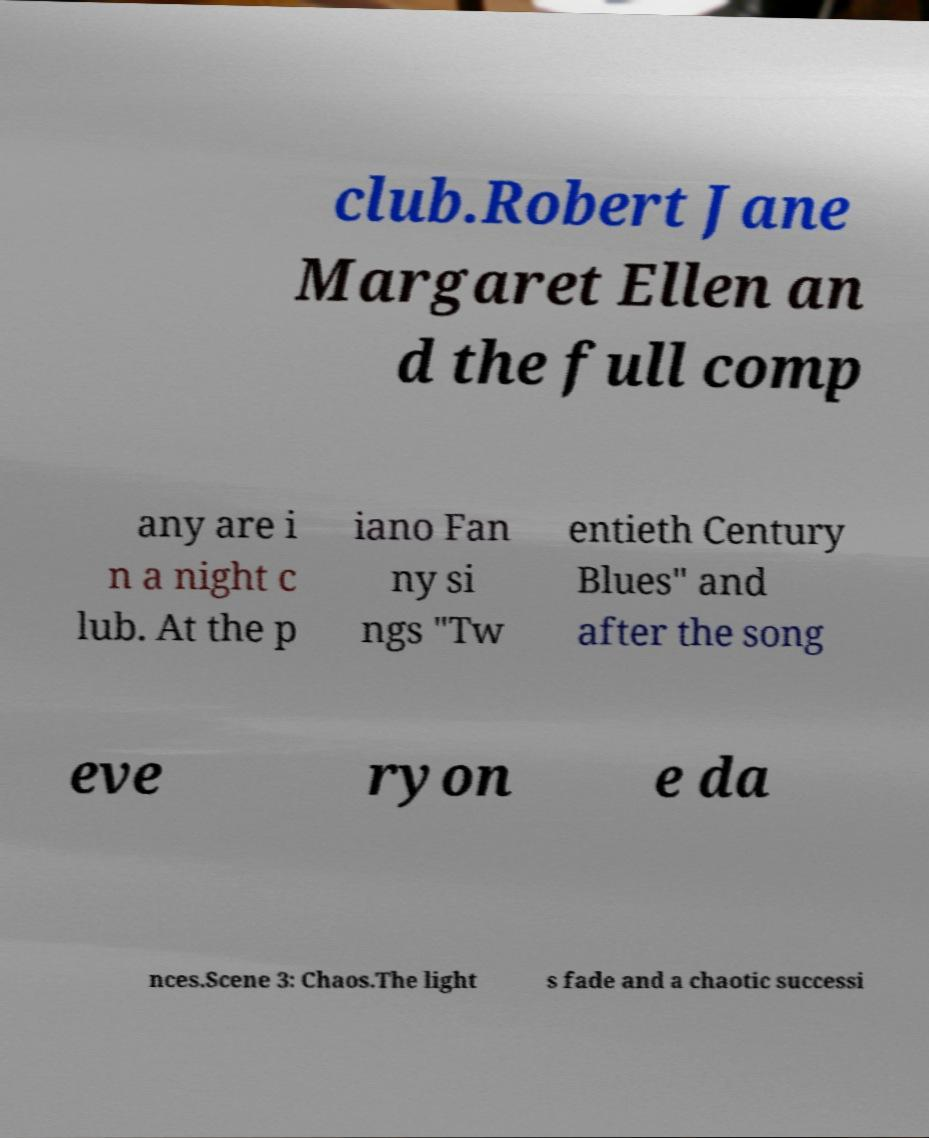What messages or text are displayed in this image? I need them in a readable, typed format. club.Robert Jane Margaret Ellen an d the full comp any are i n a night c lub. At the p iano Fan ny si ngs "Tw entieth Century Blues" and after the song eve ryon e da nces.Scene 3: Chaos.The light s fade and a chaotic successi 